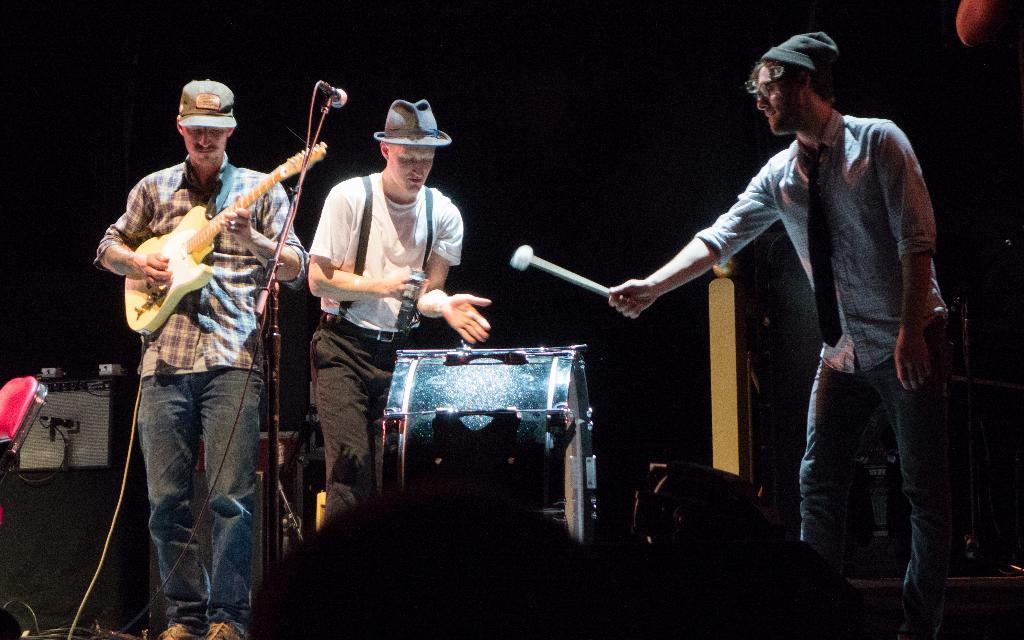Could you give a brief overview of what you see in this image? There are 3 people on the stage performing by playing musical instruments and this is a microscope. 